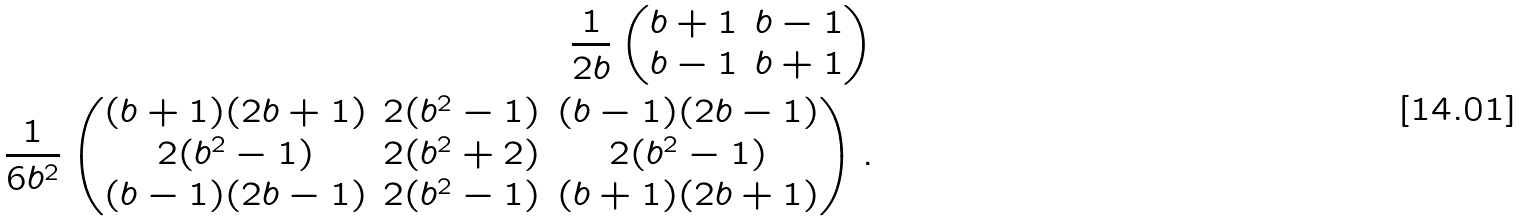Convert formula to latex. <formula><loc_0><loc_0><loc_500><loc_500>\frac { 1 } { 2 b } \begin{pmatrix} b + 1 & b - 1 \\ b - 1 & b + 1 \end{pmatrix} \\ \frac { 1 } { 6 b ^ { 2 } } \begin{pmatrix} ( b + 1 ) ( 2 b + 1 ) & 2 ( b ^ { 2 } - 1 ) & ( b - 1 ) ( 2 b - 1 ) \\ 2 ( b ^ { 2 } - 1 ) & 2 ( b ^ { 2 } + 2 ) & 2 ( b ^ { 2 } - 1 ) \\ ( b - 1 ) ( 2 b - 1 ) & 2 ( b ^ { 2 } - 1 ) & ( b + 1 ) ( 2 b + 1 ) \end{pmatrix} .</formula> 